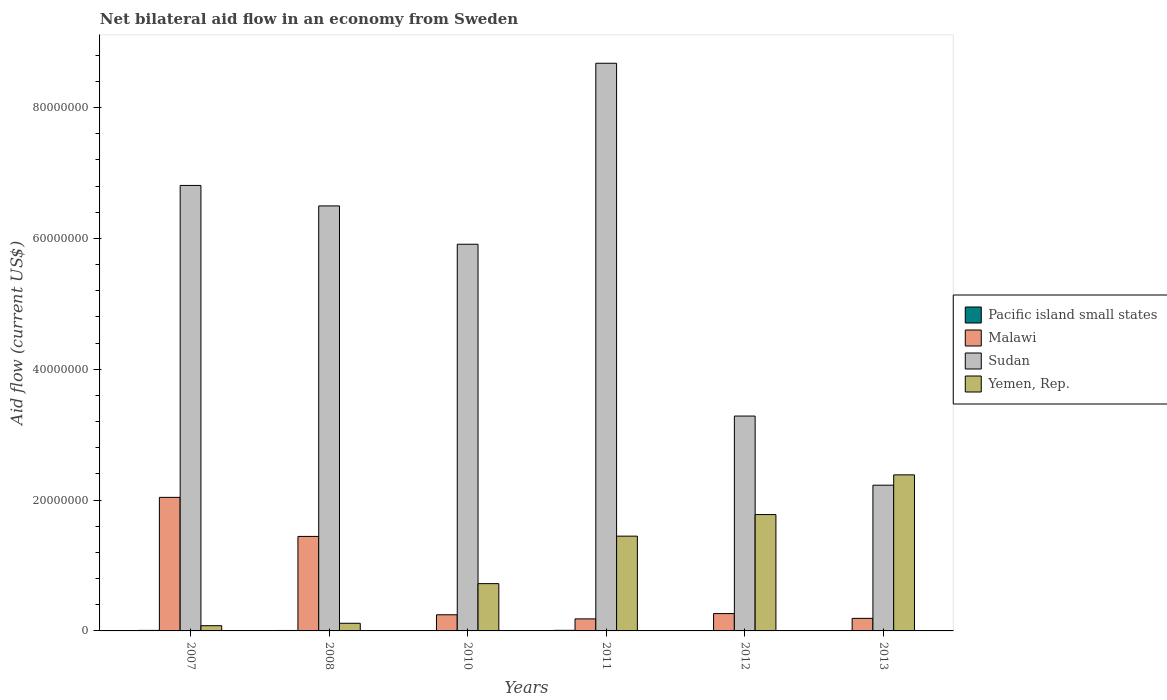How many groups of bars are there?
Your answer should be very brief. 6. How many bars are there on the 4th tick from the left?
Your response must be concise. 4. How many bars are there on the 6th tick from the right?
Your answer should be very brief. 4. In how many cases, is the number of bars for a given year not equal to the number of legend labels?
Your response must be concise. 1. What is the net bilateral aid flow in Malawi in 2011?
Offer a very short reply. 1.84e+06. Across all years, what is the maximum net bilateral aid flow in Sudan?
Make the answer very short. 8.68e+07. Across all years, what is the minimum net bilateral aid flow in Sudan?
Keep it short and to the point. 2.23e+07. What is the total net bilateral aid flow in Sudan in the graph?
Keep it short and to the point. 3.34e+08. What is the difference between the net bilateral aid flow in Yemen, Rep. in 2007 and that in 2008?
Provide a short and direct response. -3.70e+05. What is the difference between the net bilateral aid flow in Yemen, Rep. in 2010 and the net bilateral aid flow in Pacific island small states in 2013?
Keep it short and to the point. 7.20e+06. What is the average net bilateral aid flow in Sudan per year?
Ensure brevity in your answer.  5.57e+07. In the year 2011, what is the difference between the net bilateral aid flow in Sudan and net bilateral aid flow in Yemen, Rep.?
Keep it short and to the point. 7.23e+07. In how many years, is the net bilateral aid flow in Sudan greater than 68000000 US$?
Keep it short and to the point. 2. What is the ratio of the net bilateral aid flow in Yemen, Rep. in 2007 to that in 2011?
Keep it short and to the point. 0.06. Is the difference between the net bilateral aid flow in Sudan in 2012 and 2013 greater than the difference between the net bilateral aid flow in Yemen, Rep. in 2012 and 2013?
Offer a terse response. Yes. What is the difference between the highest and the second highest net bilateral aid flow in Sudan?
Provide a short and direct response. 1.87e+07. What is the difference between the highest and the lowest net bilateral aid flow in Sudan?
Offer a very short reply. 6.45e+07. Is the sum of the net bilateral aid flow in Pacific island small states in 2007 and 2010 greater than the maximum net bilateral aid flow in Sudan across all years?
Provide a succinct answer. No. Is it the case that in every year, the sum of the net bilateral aid flow in Pacific island small states and net bilateral aid flow in Yemen, Rep. is greater than the net bilateral aid flow in Malawi?
Your answer should be very brief. No. How many bars are there?
Keep it short and to the point. 23. Where does the legend appear in the graph?
Your answer should be compact. Center right. How many legend labels are there?
Offer a very short reply. 4. How are the legend labels stacked?
Offer a terse response. Vertical. What is the title of the graph?
Provide a short and direct response. Net bilateral aid flow in an economy from Sweden. What is the label or title of the Y-axis?
Offer a very short reply. Aid flow (current US$). What is the Aid flow (current US$) of Malawi in 2007?
Give a very brief answer. 2.04e+07. What is the Aid flow (current US$) in Sudan in 2007?
Offer a terse response. 6.81e+07. What is the Aid flow (current US$) of Yemen, Rep. in 2007?
Make the answer very short. 8.00e+05. What is the Aid flow (current US$) in Pacific island small states in 2008?
Provide a succinct answer. 7.00e+04. What is the Aid flow (current US$) of Malawi in 2008?
Give a very brief answer. 1.44e+07. What is the Aid flow (current US$) of Sudan in 2008?
Your answer should be compact. 6.50e+07. What is the Aid flow (current US$) of Yemen, Rep. in 2008?
Ensure brevity in your answer.  1.17e+06. What is the Aid flow (current US$) of Malawi in 2010?
Make the answer very short. 2.47e+06. What is the Aid flow (current US$) in Sudan in 2010?
Offer a very short reply. 5.91e+07. What is the Aid flow (current US$) in Yemen, Rep. in 2010?
Provide a short and direct response. 7.23e+06. What is the Aid flow (current US$) in Pacific island small states in 2011?
Give a very brief answer. 9.00e+04. What is the Aid flow (current US$) in Malawi in 2011?
Your answer should be very brief. 1.84e+06. What is the Aid flow (current US$) of Sudan in 2011?
Your response must be concise. 8.68e+07. What is the Aid flow (current US$) of Yemen, Rep. in 2011?
Provide a succinct answer. 1.45e+07. What is the Aid flow (current US$) in Pacific island small states in 2012?
Ensure brevity in your answer.  0. What is the Aid flow (current US$) in Malawi in 2012?
Your answer should be compact. 2.65e+06. What is the Aid flow (current US$) of Sudan in 2012?
Your response must be concise. 3.28e+07. What is the Aid flow (current US$) in Yemen, Rep. in 2012?
Give a very brief answer. 1.78e+07. What is the Aid flow (current US$) in Malawi in 2013?
Provide a short and direct response. 1.92e+06. What is the Aid flow (current US$) in Sudan in 2013?
Provide a succinct answer. 2.23e+07. What is the Aid flow (current US$) in Yemen, Rep. in 2013?
Offer a terse response. 2.39e+07. Across all years, what is the maximum Aid flow (current US$) of Malawi?
Your response must be concise. 2.04e+07. Across all years, what is the maximum Aid flow (current US$) of Sudan?
Your answer should be very brief. 8.68e+07. Across all years, what is the maximum Aid flow (current US$) of Yemen, Rep.?
Give a very brief answer. 2.39e+07. Across all years, what is the minimum Aid flow (current US$) of Pacific island small states?
Your answer should be very brief. 0. Across all years, what is the minimum Aid flow (current US$) in Malawi?
Keep it short and to the point. 1.84e+06. Across all years, what is the minimum Aid flow (current US$) in Sudan?
Offer a very short reply. 2.23e+07. What is the total Aid flow (current US$) in Malawi in the graph?
Your answer should be compact. 4.38e+07. What is the total Aid flow (current US$) of Sudan in the graph?
Provide a succinct answer. 3.34e+08. What is the total Aid flow (current US$) in Yemen, Rep. in the graph?
Your answer should be compact. 6.53e+07. What is the difference between the Aid flow (current US$) of Pacific island small states in 2007 and that in 2008?
Give a very brief answer. 10000. What is the difference between the Aid flow (current US$) of Malawi in 2007 and that in 2008?
Offer a terse response. 5.97e+06. What is the difference between the Aid flow (current US$) of Sudan in 2007 and that in 2008?
Your response must be concise. 3.13e+06. What is the difference between the Aid flow (current US$) in Yemen, Rep. in 2007 and that in 2008?
Give a very brief answer. -3.70e+05. What is the difference between the Aid flow (current US$) in Pacific island small states in 2007 and that in 2010?
Your answer should be compact. 6.00e+04. What is the difference between the Aid flow (current US$) of Malawi in 2007 and that in 2010?
Provide a succinct answer. 1.80e+07. What is the difference between the Aid flow (current US$) in Sudan in 2007 and that in 2010?
Offer a terse response. 8.99e+06. What is the difference between the Aid flow (current US$) in Yemen, Rep. in 2007 and that in 2010?
Ensure brevity in your answer.  -6.43e+06. What is the difference between the Aid flow (current US$) of Pacific island small states in 2007 and that in 2011?
Offer a very short reply. -10000. What is the difference between the Aid flow (current US$) of Malawi in 2007 and that in 2011?
Your answer should be compact. 1.86e+07. What is the difference between the Aid flow (current US$) in Sudan in 2007 and that in 2011?
Keep it short and to the point. -1.87e+07. What is the difference between the Aid flow (current US$) in Yemen, Rep. in 2007 and that in 2011?
Your response must be concise. -1.37e+07. What is the difference between the Aid flow (current US$) of Malawi in 2007 and that in 2012?
Your answer should be very brief. 1.78e+07. What is the difference between the Aid flow (current US$) of Sudan in 2007 and that in 2012?
Provide a succinct answer. 3.53e+07. What is the difference between the Aid flow (current US$) of Yemen, Rep. in 2007 and that in 2012?
Give a very brief answer. -1.70e+07. What is the difference between the Aid flow (current US$) in Pacific island small states in 2007 and that in 2013?
Offer a very short reply. 5.00e+04. What is the difference between the Aid flow (current US$) in Malawi in 2007 and that in 2013?
Ensure brevity in your answer.  1.85e+07. What is the difference between the Aid flow (current US$) in Sudan in 2007 and that in 2013?
Offer a very short reply. 4.58e+07. What is the difference between the Aid flow (current US$) in Yemen, Rep. in 2007 and that in 2013?
Your answer should be compact. -2.31e+07. What is the difference between the Aid flow (current US$) of Malawi in 2008 and that in 2010?
Provide a succinct answer. 1.20e+07. What is the difference between the Aid flow (current US$) of Sudan in 2008 and that in 2010?
Keep it short and to the point. 5.86e+06. What is the difference between the Aid flow (current US$) of Yemen, Rep. in 2008 and that in 2010?
Provide a short and direct response. -6.06e+06. What is the difference between the Aid flow (current US$) in Malawi in 2008 and that in 2011?
Your answer should be compact. 1.26e+07. What is the difference between the Aid flow (current US$) of Sudan in 2008 and that in 2011?
Provide a succinct answer. -2.18e+07. What is the difference between the Aid flow (current US$) in Yemen, Rep. in 2008 and that in 2011?
Offer a very short reply. -1.33e+07. What is the difference between the Aid flow (current US$) of Malawi in 2008 and that in 2012?
Your answer should be compact. 1.18e+07. What is the difference between the Aid flow (current US$) in Sudan in 2008 and that in 2012?
Provide a succinct answer. 3.21e+07. What is the difference between the Aid flow (current US$) of Yemen, Rep. in 2008 and that in 2012?
Your answer should be compact. -1.66e+07. What is the difference between the Aid flow (current US$) of Malawi in 2008 and that in 2013?
Provide a succinct answer. 1.25e+07. What is the difference between the Aid flow (current US$) of Sudan in 2008 and that in 2013?
Your answer should be very brief. 4.27e+07. What is the difference between the Aid flow (current US$) in Yemen, Rep. in 2008 and that in 2013?
Offer a terse response. -2.27e+07. What is the difference between the Aid flow (current US$) in Pacific island small states in 2010 and that in 2011?
Your answer should be compact. -7.00e+04. What is the difference between the Aid flow (current US$) in Malawi in 2010 and that in 2011?
Keep it short and to the point. 6.30e+05. What is the difference between the Aid flow (current US$) in Sudan in 2010 and that in 2011?
Offer a very short reply. -2.77e+07. What is the difference between the Aid flow (current US$) of Yemen, Rep. in 2010 and that in 2011?
Give a very brief answer. -7.26e+06. What is the difference between the Aid flow (current US$) of Malawi in 2010 and that in 2012?
Offer a terse response. -1.80e+05. What is the difference between the Aid flow (current US$) in Sudan in 2010 and that in 2012?
Provide a succinct answer. 2.63e+07. What is the difference between the Aid flow (current US$) in Yemen, Rep. in 2010 and that in 2012?
Keep it short and to the point. -1.06e+07. What is the difference between the Aid flow (current US$) in Sudan in 2010 and that in 2013?
Your response must be concise. 3.68e+07. What is the difference between the Aid flow (current US$) of Yemen, Rep. in 2010 and that in 2013?
Provide a short and direct response. -1.66e+07. What is the difference between the Aid flow (current US$) of Malawi in 2011 and that in 2012?
Offer a very short reply. -8.10e+05. What is the difference between the Aid flow (current US$) in Sudan in 2011 and that in 2012?
Your response must be concise. 5.39e+07. What is the difference between the Aid flow (current US$) of Yemen, Rep. in 2011 and that in 2012?
Offer a very short reply. -3.30e+06. What is the difference between the Aid flow (current US$) in Sudan in 2011 and that in 2013?
Your response must be concise. 6.45e+07. What is the difference between the Aid flow (current US$) in Yemen, Rep. in 2011 and that in 2013?
Offer a terse response. -9.37e+06. What is the difference between the Aid flow (current US$) in Malawi in 2012 and that in 2013?
Your answer should be compact. 7.30e+05. What is the difference between the Aid flow (current US$) of Sudan in 2012 and that in 2013?
Your answer should be compact. 1.06e+07. What is the difference between the Aid flow (current US$) in Yemen, Rep. in 2012 and that in 2013?
Ensure brevity in your answer.  -6.07e+06. What is the difference between the Aid flow (current US$) of Pacific island small states in 2007 and the Aid flow (current US$) of Malawi in 2008?
Your answer should be very brief. -1.44e+07. What is the difference between the Aid flow (current US$) of Pacific island small states in 2007 and the Aid flow (current US$) of Sudan in 2008?
Provide a short and direct response. -6.49e+07. What is the difference between the Aid flow (current US$) of Pacific island small states in 2007 and the Aid flow (current US$) of Yemen, Rep. in 2008?
Give a very brief answer. -1.09e+06. What is the difference between the Aid flow (current US$) in Malawi in 2007 and the Aid flow (current US$) in Sudan in 2008?
Your answer should be compact. -4.46e+07. What is the difference between the Aid flow (current US$) in Malawi in 2007 and the Aid flow (current US$) in Yemen, Rep. in 2008?
Your answer should be compact. 1.92e+07. What is the difference between the Aid flow (current US$) of Sudan in 2007 and the Aid flow (current US$) of Yemen, Rep. in 2008?
Ensure brevity in your answer.  6.69e+07. What is the difference between the Aid flow (current US$) of Pacific island small states in 2007 and the Aid flow (current US$) of Malawi in 2010?
Ensure brevity in your answer.  -2.39e+06. What is the difference between the Aid flow (current US$) of Pacific island small states in 2007 and the Aid flow (current US$) of Sudan in 2010?
Offer a very short reply. -5.90e+07. What is the difference between the Aid flow (current US$) in Pacific island small states in 2007 and the Aid flow (current US$) in Yemen, Rep. in 2010?
Provide a succinct answer. -7.15e+06. What is the difference between the Aid flow (current US$) in Malawi in 2007 and the Aid flow (current US$) in Sudan in 2010?
Your response must be concise. -3.87e+07. What is the difference between the Aid flow (current US$) of Malawi in 2007 and the Aid flow (current US$) of Yemen, Rep. in 2010?
Your answer should be very brief. 1.32e+07. What is the difference between the Aid flow (current US$) in Sudan in 2007 and the Aid flow (current US$) in Yemen, Rep. in 2010?
Your answer should be very brief. 6.09e+07. What is the difference between the Aid flow (current US$) of Pacific island small states in 2007 and the Aid flow (current US$) of Malawi in 2011?
Provide a succinct answer. -1.76e+06. What is the difference between the Aid flow (current US$) in Pacific island small states in 2007 and the Aid flow (current US$) in Sudan in 2011?
Provide a short and direct response. -8.67e+07. What is the difference between the Aid flow (current US$) of Pacific island small states in 2007 and the Aid flow (current US$) of Yemen, Rep. in 2011?
Your answer should be very brief. -1.44e+07. What is the difference between the Aid flow (current US$) in Malawi in 2007 and the Aid flow (current US$) in Sudan in 2011?
Provide a short and direct response. -6.64e+07. What is the difference between the Aid flow (current US$) in Malawi in 2007 and the Aid flow (current US$) in Yemen, Rep. in 2011?
Your response must be concise. 5.93e+06. What is the difference between the Aid flow (current US$) of Sudan in 2007 and the Aid flow (current US$) of Yemen, Rep. in 2011?
Ensure brevity in your answer.  5.36e+07. What is the difference between the Aid flow (current US$) in Pacific island small states in 2007 and the Aid flow (current US$) in Malawi in 2012?
Make the answer very short. -2.57e+06. What is the difference between the Aid flow (current US$) of Pacific island small states in 2007 and the Aid flow (current US$) of Sudan in 2012?
Offer a very short reply. -3.28e+07. What is the difference between the Aid flow (current US$) in Pacific island small states in 2007 and the Aid flow (current US$) in Yemen, Rep. in 2012?
Offer a terse response. -1.77e+07. What is the difference between the Aid flow (current US$) in Malawi in 2007 and the Aid flow (current US$) in Sudan in 2012?
Offer a very short reply. -1.24e+07. What is the difference between the Aid flow (current US$) of Malawi in 2007 and the Aid flow (current US$) of Yemen, Rep. in 2012?
Your answer should be compact. 2.63e+06. What is the difference between the Aid flow (current US$) of Sudan in 2007 and the Aid flow (current US$) of Yemen, Rep. in 2012?
Provide a succinct answer. 5.03e+07. What is the difference between the Aid flow (current US$) of Pacific island small states in 2007 and the Aid flow (current US$) of Malawi in 2013?
Make the answer very short. -1.84e+06. What is the difference between the Aid flow (current US$) of Pacific island small states in 2007 and the Aid flow (current US$) of Sudan in 2013?
Offer a terse response. -2.22e+07. What is the difference between the Aid flow (current US$) in Pacific island small states in 2007 and the Aid flow (current US$) in Yemen, Rep. in 2013?
Offer a terse response. -2.38e+07. What is the difference between the Aid flow (current US$) of Malawi in 2007 and the Aid flow (current US$) of Sudan in 2013?
Keep it short and to the point. -1.86e+06. What is the difference between the Aid flow (current US$) in Malawi in 2007 and the Aid flow (current US$) in Yemen, Rep. in 2013?
Offer a very short reply. -3.44e+06. What is the difference between the Aid flow (current US$) in Sudan in 2007 and the Aid flow (current US$) in Yemen, Rep. in 2013?
Ensure brevity in your answer.  4.42e+07. What is the difference between the Aid flow (current US$) in Pacific island small states in 2008 and the Aid flow (current US$) in Malawi in 2010?
Provide a short and direct response. -2.40e+06. What is the difference between the Aid flow (current US$) of Pacific island small states in 2008 and the Aid flow (current US$) of Sudan in 2010?
Provide a short and direct response. -5.90e+07. What is the difference between the Aid flow (current US$) of Pacific island small states in 2008 and the Aid flow (current US$) of Yemen, Rep. in 2010?
Your answer should be compact. -7.16e+06. What is the difference between the Aid flow (current US$) of Malawi in 2008 and the Aid flow (current US$) of Sudan in 2010?
Ensure brevity in your answer.  -4.47e+07. What is the difference between the Aid flow (current US$) of Malawi in 2008 and the Aid flow (current US$) of Yemen, Rep. in 2010?
Your response must be concise. 7.22e+06. What is the difference between the Aid flow (current US$) of Sudan in 2008 and the Aid flow (current US$) of Yemen, Rep. in 2010?
Offer a very short reply. 5.78e+07. What is the difference between the Aid flow (current US$) of Pacific island small states in 2008 and the Aid flow (current US$) of Malawi in 2011?
Offer a terse response. -1.77e+06. What is the difference between the Aid flow (current US$) in Pacific island small states in 2008 and the Aid flow (current US$) in Sudan in 2011?
Make the answer very short. -8.67e+07. What is the difference between the Aid flow (current US$) in Pacific island small states in 2008 and the Aid flow (current US$) in Yemen, Rep. in 2011?
Offer a terse response. -1.44e+07. What is the difference between the Aid flow (current US$) of Malawi in 2008 and the Aid flow (current US$) of Sudan in 2011?
Ensure brevity in your answer.  -7.23e+07. What is the difference between the Aid flow (current US$) in Malawi in 2008 and the Aid flow (current US$) in Yemen, Rep. in 2011?
Provide a short and direct response. -4.00e+04. What is the difference between the Aid flow (current US$) in Sudan in 2008 and the Aid flow (current US$) in Yemen, Rep. in 2011?
Provide a short and direct response. 5.05e+07. What is the difference between the Aid flow (current US$) of Pacific island small states in 2008 and the Aid flow (current US$) of Malawi in 2012?
Offer a terse response. -2.58e+06. What is the difference between the Aid flow (current US$) in Pacific island small states in 2008 and the Aid flow (current US$) in Sudan in 2012?
Make the answer very short. -3.28e+07. What is the difference between the Aid flow (current US$) of Pacific island small states in 2008 and the Aid flow (current US$) of Yemen, Rep. in 2012?
Your response must be concise. -1.77e+07. What is the difference between the Aid flow (current US$) in Malawi in 2008 and the Aid flow (current US$) in Sudan in 2012?
Offer a very short reply. -1.84e+07. What is the difference between the Aid flow (current US$) of Malawi in 2008 and the Aid flow (current US$) of Yemen, Rep. in 2012?
Give a very brief answer. -3.34e+06. What is the difference between the Aid flow (current US$) of Sudan in 2008 and the Aid flow (current US$) of Yemen, Rep. in 2012?
Ensure brevity in your answer.  4.72e+07. What is the difference between the Aid flow (current US$) in Pacific island small states in 2008 and the Aid flow (current US$) in Malawi in 2013?
Keep it short and to the point. -1.85e+06. What is the difference between the Aid flow (current US$) in Pacific island small states in 2008 and the Aid flow (current US$) in Sudan in 2013?
Your response must be concise. -2.22e+07. What is the difference between the Aid flow (current US$) in Pacific island small states in 2008 and the Aid flow (current US$) in Yemen, Rep. in 2013?
Keep it short and to the point. -2.38e+07. What is the difference between the Aid flow (current US$) in Malawi in 2008 and the Aid flow (current US$) in Sudan in 2013?
Ensure brevity in your answer.  -7.83e+06. What is the difference between the Aid flow (current US$) in Malawi in 2008 and the Aid flow (current US$) in Yemen, Rep. in 2013?
Your response must be concise. -9.41e+06. What is the difference between the Aid flow (current US$) in Sudan in 2008 and the Aid flow (current US$) in Yemen, Rep. in 2013?
Offer a very short reply. 4.11e+07. What is the difference between the Aid flow (current US$) of Pacific island small states in 2010 and the Aid flow (current US$) of Malawi in 2011?
Provide a short and direct response. -1.82e+06. What is the difference between the Aid flow (current US$) of Pacific island small states in 2010 and the Aid flow (current US$) of Sudan in 2011?
Offer a terse response. -8.68e+07. What is the difference between the Aid flow (current US$) in Pacific island small states in 2010 and the Aid flow (current US$) in Yemen, Rep. in 2011?
Make the answer very short. -1.45e+07. What is the difference between the Aid flow (current US$) of Malawi in 2010 and the Aid flow (current US$) of Sudan in 2011?
Offer a terse response. -8.43e+07. What is the difference between the Aid flow (current US$) in Malawi in 2010 and the Aid flow (current US$) in Yemen, Rep. in 2011?
Ensure brevity in your answer.  -1.20e+07. What is the difference between the Aid flow (current US$) in Sudan in 2010 and the Aid flow (current US$) in Yemen, Rep. in 2011?
Make the answer very short. 4.46e+07. What is the difference between the Aid flow (current US$) of Pacific island small states in 2010 and the Aid flow (current US$) of Malawi in 2012?
Your answer should be compact. -2.63e+06. What is the difference between the Aid flow (current US$) of Pacific island small states in 2010 and the Aid flow (current US$) of Sudan in 2012?
Your response must be concise. -3.28e+07. What is the difference between the Aid flow (current US$) of Pacific island small states in 2010 and the Aid flow (current US$) of Yemen, Rep. in 2012?
Give a very brief answer. -1.78e+07. What is the difference between the Aid flow (current US$) of Malawi in 2010 and the Aid flow (current US$) of Sudan in 2012?
Ensure brevity in your answer.  -3.04e+07. What is the difference between the Aid flow (current US$) in Malawi in 2010 and the Aid flow (current US$) in Yemen, Rep. in 2012?
Your response must be concise. -1.53e+07. What is the difference between the Aid flow (current US$) of Sudan in 2010 and the Aid flow (current US$) of Yemen, Rep. in 2012?
Provide a succinct answer. 4.13e+07. What is the difference between the Aid flow (current US$) in Pacific island small states in 2010 and the Aid flow (current US$) in Malawi in 2013?
Keep it short and to the point. -1.90e+06. What is the difference between the Aid flow (current US$) of Pacific island small states in 2010 and the Aid flow (current US$) of Sudan in 2013?
Your response must be concise. -2.23e+07. What is the difference between the Aid flow (current US$) in Pacific island small states in 2010 and the Aid flow (current US$) in Yemen, Rep. in 2013?
Your answer should be very brief. -2.38e+07. What is the difference between the Aid flow (current US$) in Malawi in 2010 and the Aid flow (current US$) in Sudan in 2013?
Your answer should be compact. -1.98e+07. What is the difference between the Aid flow (current US$) in Malawi in 2010 and the Aid flow (current US$) in Yemen, Rep. in 2013?
Offer a very short reply. -2.14e+07. What is the difference between the Aid flow (current US$) in Sudan in 2010 and the Aid flow (current US$) in Yemen, Rep. in 2013?
Your answer should be very brief. 3.53e+07. What is the difference between the Aid flow (current US$) in Pacific island small states in 2011 and the Aid flow (current US$) in Malawi in 2012?
Keep it short and to the point. -2.56e+06. What is the difference between the Aid flow (current US$) of Pacific island small states in 2011 and the Aid flow (current US$) of Sudan in 2012?
Ensure brevity in your answer.  -3.28e+07. What is the difference between the Aid flow (current US$) of Pacific island small states in 2011 and the Aid flow (current US$) of Yemen, Rep. in 2012?
Provide a succinct answer. -1.77e+07. What is the difference between the Aid flow (current US$) in Malawi in 2011 and the Aid flow (current US$) in Sudan in 2012?
Ensure brevity in your answer.  -3.10e+07. What is the difference between the Aid flow (current US$) of Malawi in 2011 and the Aid flow (current US$) of Yemen, Rep. in 2012?
Your response must be concise. -1.60e+07. What is the difference between the Aid flow (current US$) of Sudan in 2011 and the Aid flow (current US$) of Yemen, Rep. in 2012?
Provide a succinct answer. 6.90e+07. What is the difference between the Aid flow (current US$) of Pacific island small states in 2011 and the Aid flow (current US$) of Malawi in 2013?
Offer a very short reply. -1.83e+06. What is the difference between the Aid flow (current US$) in Pacific island small states in 2011 and the Aid flow (current US$) in Sudan in 2013?
Provide a succinct answer. -2.22e+07. What is the difference between the Aid flow (current US$) of Pacific island small states in 2011 and the Aid flow (current US$) of Yemen, Rep. in 2013?
Provide a short and direct response. -2.38e+07. What is the difference between the Aid flow (current US$) in Malawi in 2011 and the Aid flow (current US$) in Sudan in 2013?
Your answer should be very brief. -2.04e+07. What is the difference between the Aid flow (current US$) of Malawi in 2011 and the Aid flow (current US$) of Yemen, Rep. in 2013?
Your answer should be compact. -2.20e+07. What is the difference between the Aid flow (current US$) in Sudan in 2011 and the Aid flow (current US$) in Yemen, Rep. in 2013?
Ensure brevity in your answer.  6.29e+07. What is the difference between the Aid flow (current US$) of Malawi in 2012 and the Aid flow (current US$) of Sudan in 2013?
Your response must be concise. -1.96e+07. What is the difference between the Aid flow (current US$) in Malawi in 2012 and the Aid flow (current US$) in Yemen, Rep. in 2013?
Offer a terse response. -2.12e+07. What is the difference between the Aid flow (current US$) in Sudan in 2012 and the Aid flow (current US$) in Yemen, Rep. in 2013?
Offer a terse response. 8.99e+06. What is the average Aid flow (current US$) in Pacific island small states per year?
Make the answer very short. 4.83e+04. What is the average Aid flow (current US$) in Malawi per year?
Offer a terse response. 7.29e+06. What is the average Aid flow (current US$) in Sudan per year?
Offer a very short reply. 5.57e+07. What is the average Aid flow (current US$) of Yemen, Rep. per year?
Keep it short and to the point. 1.09e+07. In the year 2007, what is the difference between the Aid flow (current US$) of Pacific island small states and Aid flow (current US$) of Malawi?
Your answer should be very brief. -2.03e+07. In the year 2007, what is the difference between the Aid flow (current US$) of Pacific island small states and Aid flow (current US$) of Sudan?
Your response must be concise. -6.80e+07. In the year 2007, what is the difference between the Aid flow (current US$) in Pacific island small states and Aid flow (current US$) in Yemen, Rep.?
Make the answer very short. -7.20e+05. In the year 2007, what is the difference between the Aid flow (current US$) in Malawi and Aid flow (current US$) in Sudan?
Your response must be concise. -4.77e+07. In the year 2007, what is the difference between the Aid flow (current US$) in Malawi and Aid flow (current US$) in Yemen, Rep.?
Your response must be concise. 1.96e+07. In the year 2007, what is the difference between the Aid flow (current US$) in Sudan and Aid flow (current US$) in Yemen, Rep.?
Your answer should be very brief. 6.73e+07. In the year 2008, what is the difference between the Aid flow (current US$) in Pacific island small states and Aid flow (current US$) in Malawi?
Your answer should be very brief. -1.44e+07. In the year 2008, what is the difference between the Aid flow (current US$) of Pacific island small states and Aid flow (current US$) of Sudan?
Make the answer very short. -6.49e+07. In the year 2008, what is the difference between the Aid flow (current US$) of Pacific island small states and Aid flow (current US$) of Yemen, Rep.?
Provide a succinct answer. -1.10e+06. In the year 2008, what is the difference between the Aid flow (current US$) of Malawi and Aid flow (current US$) of Sudan?
Your answer should be compact. -5.05e+07. In the year 2008, what is the difference between the Aid flow (current US$) of Malawi and Aid flow (current US$) of Yemen, Rep.?
Your answer should be compact. 1.33e+07. In the year 2008, what is the difference between the Aid flow (current US$) in Sudan and Aid flow (current US$) in Yemen, Rep.?
Offer a terse response. 6.38e+07. In the year 2010, what is the difference between the Aid flow (current US$) of Pacific island small states and Aid flow (current US$) of Malawi?
Give a very brief answer. -2.45e+06. In the year 2010, what is the difference between the Aid flow (current US$) in Pacific island small states and Aid flow (current US$) in Sudan?
Make the answer very short. -5.91e+07. In the year 2010, what is the difference between the Aid flow (current US$) in Pacific island small states and Aid flow (current US$) in Yemen, Rep.?
Make the answer very short. -7.21e+06. In the year 2010, what is the difference between the Aid flow (current US$) of Malawi and Aid flow (current US$) of Sudan?
Your answer should be compact. -5.66e+07. In the year 2010, what is the difference between the Aid flow (current US$) of Malawi and Aid flow (current US$) of Yemen, Rep.?
Offer a very short reply. -4.76e+06. In the year 2010, what is the difference between the Aid flow (current US$) of Sudan and Aid flow (current US$) of Yemen, Rep.?
Provide a succinct answer. 5.19e+07. In the year 2011, what is the difference between the Aid flow (current US$) of Pacific island small states and Aid flow (current US$) of Malawi?
Offer a very short reply. -1.75e+06. In the year 2011, what is the difference between the Aid flow (current US$) of Pacific island small states and Aid flow (current US$) of Sudan?
Offer a terse response. -8.67e+07. In the year 2011, what is the difference between the Aid flow (current US$) in Pacific island small states and Aid flow (current US$) in Yemen, Rep.?
Provide a succinct answer. -1.44e+07. In the year 2011, what is the difference between the Aid flow (current US$) of Malawi and Aid flow (current US$) of Sudan?
Offer a terse response. -8.50e+07. In the year 2011, what is the difference between the Aid flow (current US$) in Malawi and Aid flow (current US$) in Yemen, Rep.?
Ensure brevity in your answer.  -1.26e+07. In the year 2011, what is the difference between the Aid flow (current US$) in Sudan and Aid flow (current US$) in Yemen, Rep.?
Give a very brief answer. 7.23e+07. In the year 2012, what is the difference between the Aid flow (current US$) of Malawi and Aid flow (current US$) of Sudan?
Offer a very short reply. -3.02e+07. In the year 2012, what is the difference between the Aid flow (current US$) of Malawi and Aid flow (current US$) of Yemen, Rep.?
Give a very brief answer. -1.51e+07. In the year 2012, what is the difference between the Aid flow (current US$) of Sudan and Aid flow (current US$) of Yemen, Rep.?
Your answer should be very brief. 1.51e+07. In the year 2013, what is the difference between the Aid flow (current US$) of Pacific island small states and Aid flow (current US$) of Malawi?
Your response must be concise. -1.89e+06. In the year 2013, what is the difference between the Aid flow (current US$) of Pacific island small states and Aid flow (current US$) of Sudan?
Your answer should be compact. -2.22e+07. In the year 2013, what is the difference between the Aid flow (current US$) in Pacific island small states and Aid flow (current US$) in Yemen, Rep.?
Provide a short and direct response. -2.38e+07. In the year 2013, what is the difference between the Aid flow (current US$) of Malawi and Aid flow (current US$) of Sudan?
Provide a succinct answer. -2.04e+07. In the year 2013, what is the difference between the Aid flow (current US$) in Malawi and Aid flow (current US$) in Yemen, Rep.?
Offer a terse response. -2.19e+07. In the year 2013, what is the difference between the Aid flow (current US$) in Sudan and Aid flow (current US$) in Yemen, Rep.?
Your answer should be compact. -1.58e+06. What is the ratio of the Aid flow (current US$) of Pacific island small states in 2007 to that in 2008?
Offer a very short reply. 1.14. What is the ratio of the Aid flow (current US$) of Malawi in 2007 to that in 2008?
Make the answer very short. 1.41. What is the ratio of the Aid flow (current US$) of Sudan in 2007 to that in 2008?
Offer a terse response. 1.05. What is the ratio of the Aid flow (current US$) of Yemen, Rep. in 2007 to that in 2008?
Provide a short and direct response. 0.68. What is the ratio of the Aid flow (current US$) in Pacific island small states in 2007 to that in 2010?
Your answer should be very brief. 4. What is the ratio of the Aid flow (current US$) in Malawi in 2007 to that in 2010?
Ensure brevity in your answer.  8.27. What is the ratio of the Aid flow (current US$) of Sudan in 2007 to that in 2010?
Give a very brief answer. 1.15. What is the ratio of the Aid flow (current US$) of Yemen, Rep. in 2007 to that in 2010?
Your response must be concise. 0.11. What is the ratio of the Aid flow (current US$) in Malawi in 2007 to that in 2011?
Ensure brevity in your answer.  11.1. What is the ratio of the Aid flow (current US$) of Sudan in 2007 to that in 2011?
Keep it short and to the point. 0.78. What is the ratio of the Aid flow (current US$) of Yemen, Rep. in 2007 to that in 2011?
Provide a short and direct response. 0.06. What is the ratio of the Aid flow (current US$) in Malawi in 2007 to that in 2012?
Your answer should be very brief. 7.71. What is the ratio of the Aid flow (current US$) of Sudan in 2007 to that in 2012?
Keep it short and to the point. 2.07. What is the ratio of the Aid flow (current US$) in Yemen, Rep. in 2007 to that in 2012?
Ensure brevity in your answer.  0.04. What is the ratio of the Aid flow (current US$) in Pacific island small states in 2007 to that in 2013?
Give a very brief answer. 2.67. What is the ratio of the Aid flow (current US$) of Malawi in 2007 to that in 2013?
Offer a terse response. 10.64. What is the ratio of the Aid flow (current US$) in Sudan in 2007 to that in 2013?
Give a very brief answer. 3.06. What is the ratio of the Aid flow (current US$) of Yemen, Rep. in 2007 to that in 2013?
Ensure brevity in your answer.  0.03. What is the ratio of the Aid flow (current US$) of Pacific island small states in 2008 to that in 2010?
Offer a terse response. 3.5. What is the ratio of the Aid flow (current US$) in Malawi in 2008 to that in 2010?
Your answer should be very brief. 5.85. What is the ratio of the Aid flow (current US$) of Sudan in 2008 to that in 2010?
Ensure brevity in your answer.  1.1. What is the ratio of the Aid flow (current US$) of Yemen, Rep. in 2008 to that in 2010?
Make the answer very short. 0.16. What is the ratio of the Aid flow (current US$) of Malawi in 2008 to that in 2011?
Your response must be concise. 7.85. What is the ratio of the Aid flow (current US$) of Sudan in 2008 to that in 2011?
Ensure brevity in your answer.  0.75. What is the ratio of the Aid flow (current US$) of Yemen, Rep. in 2008 to that in 2011?
Offer a terse response. 0.08. What is the ratio of the Aid flow (current US$) in Malawi in 2008 to that in 2012?
Provide a short and direct response. 5.45. What is the ratio of the Aid flow (current US$) of Sudan in 2008 to that in 2012?
Your answer should be compact. 1.98. What is the ratio of the Aid flow (current US$) of Yemen, Rep. in 2008 to that in 2012?
Make the answer very short. 0.07. What is the ratio of the Aid flow (current US$) in Pacific island small states in 2008 to that in 2013?
Offer a very short reply. 2.33. What is the ratio of the Aid flow (current US$) in Malawi in 2008 to that in 2013?
Your response must be concise. 7.53. What is the ratio of the Aid flow (current US$) of Sudan in 2008 to that in 2013?
Your answer should be very brief. 2.92. What is the ratio of the Aid flow (current US$) of Yemen, Rep. in 2008 to that in 2013?
Your response must be concise. 0.05. What is the ratio of the Aid flow (current US$) in Pacific island small states in 2010 to that in 2011?
Offer a terse response. 0.22. What is the ratio of the Aid flow (current US$) of Malawi in 2010 to that in 2011?
Offer a very short reply. 1.34. What is the ratio of the Aid flow (current US$) in Sudan in 2010 to that in 2011?
Offer a very short reply. 0.68. What is the ratio of the Aid flow (current US$) in Yemen, Rep. in 2010 to that in 2011?
Keep it short and to the point. 0.5. What is the ratio of the Aid flow (current US$) in Malawi in 2010 to that in 2012?
Ensure brevity in your answer.  0.93. What is the ratio of the Aid flow (current US$) in Sudan in 2010 to that in 2012?
Offer a terse response. 1.8. What is the ratio of the Aid flow (current US$) in Yemen, Rep. in 2010 to that in 2012?
Offer a very short reply. 0.41. What is the ratio of the Aid flow (current US$) of Malawi in 2010 to that in 2013?
Offer a terse response. 1.29. What is the ratio of the Aid flow (current US$) in Sudan in 2010 to that in 2013?
Provide a succinct answer. 2.65. What is the ratio of the Aid flow (current US$) of Yemen, Rep. in 2010 to that in 2013?
Offer a very short reply. 0.3. What is the ratio of the Aid flow (current US$) of Malawi in 2011 to that in 2012?
Offer a terse response. 0.69. What is the ratio of the Aid flow (current US$) in Sudan in 2011 to that in 2012?
Make the answer very short. 2.64. What is the ratio of the Aid flow (current US$) in Yemen, Rep. in 2011 to that in 2012?
Your response must be concise. 0.81. What is the ratio of the Aid flow (current US$) in Sudan in 2011 to that in 2013?
Keep it short and to the point. 3.9. What is the ratio of the Aid flow (current US$) of Yemen, Rep. in 2011 to that in 2013?
Offer a terse response. 0.61. What is the ratio of the Aid flow (current US$) in Malawi in 2012 to that in 2013?
Your answer should be very brief. 1.38. What is the ratio of the Aid flow (current US$) of Sudan in 2012 to that in 2013?
Provide a short and direct response. 1.47. What is the ratio of the Aid flow (current US$) of Yemen, Rep. in 2012 to that in 2013?
Offer a very short reply. 0.75. What is the difference between the highest and the second highest Aid flow (current US$) in Pacific island small states?
Ensure brevity in your answer.  10000. What is the difference between the highest and the second highest Aid flow (current US$) in Malawi?
Your response must be concise. 5.97e+06. What is the difference between the highest and the second highest Aid flow (current US$) in Sudan?
Offer a terse response. 1.87e+07. What is the difference between the highest and the second highest Aid flow (current US$) in Yemen, Rep.?
Provide a short and direct response. 6.07e+06. What is the difference between the highest and the lowest Aid flow (current US$) in Pacific island small states?
Provide a short and direct response. 9.00e+04. What is the difference between the highest and the lowest Aid flow (current US$) of Malawi?
Give a very brief answer. 1.86e+07. What is the difference between the highest and the lowest Aid flow (current US$) of Sudan?
Keep it short and to the point. 6.45e+07. What is the difference between the highest and the lowest Aid flow (current US$) of Yemen, Rep.?
Provide a succinct answer. 2.31e+07. 